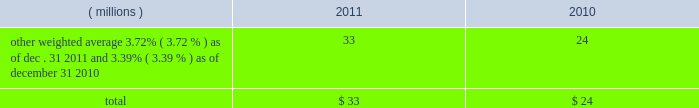Notes to the consolidated financial statements at a price equal to 101% ( 101 % ) of their principal amount plus accrued and unpaid interest .
Cash proceeds from the sale of these notes was $ 983 million ( net of discount and issuance costs ) .
The discount and issuance costs related to these notes , which totaled $ 17 million , will be amortized to interest expense over the respective terms of the notes .
In august 2010 , ppg entered into a three-year credit agreement with several banks and financial institutions ( the 201ccredit agreement 201d ) .
The credit agreement provides for a $ 1.2 billion unsecured revolving credit facility .
In connection with entering into this credit agreement , the company terminated its 20ac650 million and its $ 1 billion revolving credit facilities that were each set to expire in 2011 .
There were no outstanding amounts due under either revolving facility at the times of their termination .
The company has the ability to increase the size of the credit agreement by up to an additional $ 300 million , subject to the receipt of lender commitments and other conditions .
The credit agreement will terminate and all amounts outstanding will be due and payable on august 5 , 2013 .
The credit agreement provides that loans will bear interest at rates based , at the company 2019s option , on one of two specified base rates plus a margin based on certain formulas defined in the credit agreement .
Additionally , the credit agreement contains a commitment fee on the amount of unused commitment under the credit agreement ranging from 0.125% ( 0.125 % ) to 0.625% ( 0.625 % ) per annum .
The applicable interest rate and the fee will vary depending on the ratings established by standard & poor 2019s financial services llc and moody 2019s investor service inc .
For the company 2019s non-credit enhanced , long- term , senior , unsecured debt .
There were no amounts outstanding under the credit agreement at december 31 , 2011 ; however , the available borrowing rate on a one month , u.s .
Dollar denominated borrowing would have been 1.05 percent .
The credit agreement contains usual and customary restrictive covenants for facilities of its type , which include , with specified exceptions , limitations on the company 2019s ability to create liens or other encumbrances , to enter into sale and leaseback transactions and to enter into consolidations , mergers or transfers of all or substantially all of its assets .
The credit agreement also requires the company to maintain a ratio of total indebtedness to total capitalization , as defined in the credit agreement , of 60 percent or less .
The credit agreement contains customary events of default that would permit the lenders to accelerate the repayment of any loans , including the failure to make timely payments when due under the credit agreement or other material indebtedness , the failure to satisfy covenants contained in the credit agreement , a change in control of the company and specified events of bankruptcy and insolvency .
Ppg 2019s non-u.s .
Operations have uncommitted lines of credit totaling $ 679 million of which $ 36 million was used as of december 31 , 2011 .
These uncommitted lines of credit are subject to cancellation at any time and are generally not subject to any commitment fees .
Short-term debt outstanding as of december 31 , 2011 and 2010 , was as follows : ( millions ) 2011 2010 other , weighted average 3.72% ( 3.72 % ) as of dec .
31 , 2011 and 3.39% ( 3.39 % ) as of december 31 , 2010 33 24 total $ 33 $ 24 ppg is in compliance with the restrictive covenants under its various credit agreements , loan agreements and indentures .
The company 2019s revolving credit agreements include a financial ratio covenant .
The covenant requires that the amount of total indebtedness not exceed 60% ( 60 % ) of the company 2019s total capitalization excluding the portion of accumulated other comprehensive income ( loss ) related to pensions and other postretirement benefit adjustments .
As of december 31 , 2011 , total indebtedness was 43 percent of the company 2019s total capitalization excluding the portion of accumulated other comprehensive income ( loss ) related to pensions and other postretirement benefit adjustments .
Additionally , substantially all of the company 2019s debt agreements contain customary cross-default provisions .
Those provisions generally provide that a default on a debt service payment of $ 10 million or more for longer than the grace period provided ( usually 10 days ) under one agreement may result in an event of default under other agreements .
None of the company 2019s primary debt obligations are secured or guaranteed by the company 2019s affiliates .
Interest payments in 2011 , 2010 and 2009 totaled $ 212 million , $ 189 million and $ 201 million , respectively .
In october 2009 , the company entered into an agreement with a counterparty to repurchase up to 1.2 million shares of the company 2019s stock of which 1.1 million shares were purchased in the open market ( 465006 of these shares were purchased as of december 31 , 2009 at a weighted average price of $ 56.66 per share ) .
The counterparty held the shares until september of 2010 when the company paid $ 65 million and took possession of these shares .
In december 2008 , the company entered into an agreement with a counterparty to repurchase 1.5 million 44 2011 ppg annual report and form 10-k .
Notes to the consolidated financial statements at a price equal to 101% ( 101 % ) of their principal amount plus accrued and unpaid interest .
Cash proceeds from the sale of these notes was $ 983 million ( net of discount and issuance costs ) .
The discount and issuance costs related to these notes , which totaled $ 17 million , will be amortized to interest expense over the respective terms of the notes .
In august 2010 , ppg entered into a three-year credit agreement with several banks and financial institutions ( the 201ccredit agreement 201d ) .
The credit agreement provides for a $ 1.2 billion unsecured revolving credit facility .
In connection with entering into this credit agreement , the company terminated its 20ac650 million and its $ 1 billion revolving credit facilities that were each set to expire in 2011 .
There were no outstanding amounts due under either revolving facility at the times of their termination .
The company has the ability to increase the size of the credit agreement by up to an additional $ 300 million , subject to the receipt of lender commitments and other conditions .
The credit agreement will terminate and all amounts outstanding will be due and payable on august 5 , 2013 .
The credit agreement provides that loans will bear interest at rates based , at the company 2019s option , on one of two specified base rates plus a margin based on certain formulas defined in the credit agreement .
Additionally , the credit agreement contains a commitment fee on the amount of unused commitment under the credit agreement ranging from 0.125% ( 0.125 % ) to 0.625% ( 0.625 % ) per annum .
The applicable interest rate and the fee will vary depending on the ratings established by standard & poor 2019s financial services llc and moody 2019s investor service inc .
For the company 2019s non-credit enhanced , long- term , senior , unsecured debt .
There were no amounts outstanding under the credit agreement at december 31 , 2011 ; however , the available borrowing rate on a one month , u.s .
Dollar denominated borrowing would have been 1.05 percent .
The credit agreement contains usual and customary restrictive covenants for facilities of its type , which include , with specified exceptions , limitations on the company 2019s ability to create liens or other encumbrances , to enter into sale and leaseback transactions and to enter into consolidations , mergers or transfers of all or substantially all of its assets .
The credit agreement also requires the company to maintain a ratio of total indebtedness to total capitalization , as defined in the credit agreement , of 60 percent or less .
The credit agreement contains customary events of default that would permit the lenders to accelerate the repayment of any loans , including the failure to make timely payments when due under the credit agreement or other material indebtedness , the failure to satisfy covenants contained in the credit agreement , a change in control of the company and specified events of bankruptcy and insolvency .
Ppg 2019s non-u.s .
Operations have uncommitted lines of credit totaling $ 679 million of which $ 36 million was used as of december 31 , 2011 .
These uncommitted lines of credit are subject to cancellation at any time and are generally not subject to any commitment fees .
Short-term debt outstanding as of december 31 , 2011 and 2010 , was as follows : ( millions ) 2011 2010 other , weighted average 3.72% ( 3.72 % ) as of dec .
31 , 2011 and 3.39% ( 3.39 % ) as of december 31 , 2010 33 24 total $ 33 $ 24 ppg is in compliance with the restrictive covenants under its various credit agreements , loan agreements and indentures .
The company 2019s revolving credit agreements include a financial ratio covenant .
The covenant requires that the amount of total indebtedness not exceed 60% ( 60 % ) of the company 2019s total capitalization excluding the portion of accumulated other comprehensive income ( loss ) related to pensions and other postretirement benefit adjustments .
As of december 31 , 2011 , total indebtedness was 43 percent of the company 2019s total capitalization excluding the portion of accumulated other comprehensive income ( loss ) related to pensions and other postretirement benefit adjustments .
Additionally , substantially all of the company 2019s debt agreements contain customary cross-default provisions .
Those provisions generally provide that a default on a debt service payment of $ 10 million or more for longer than the grace period provided ( usually 10 days ) under one agreement may result in an event of default under other agreements .
None of the company 2019s primary debt obligations are secured or guaranteed by the company 2019s affiliates .
Interest payments in 2011 , 2010 and 2009 totaled $ 212 million , $ 189 million and $ 201 million , respectively .
In october 2009 , the company entered into an agreement with a counterparty to repurchase up to 1.2 million shares of the company 2019s stock of which 1.1 million shares were purchased in the open market ( 465006 of these shares were purchased as of december 31 , 2009 at a weighted average price of $ 56.66 per share ) .
The counterparty held the shares until september of 2010 when the company paid $ 65 million and took possession of these shares .
In december 2008 , the company entered into an agreement with a counterparty to repurchase 1.5 million 44 2011 ppg annual report and form 10-k .
What was the percentage change in total interest payments from 2010 to 2011? 
Computations: ((212 - 189) / 189)
Answer: 0.12169. 